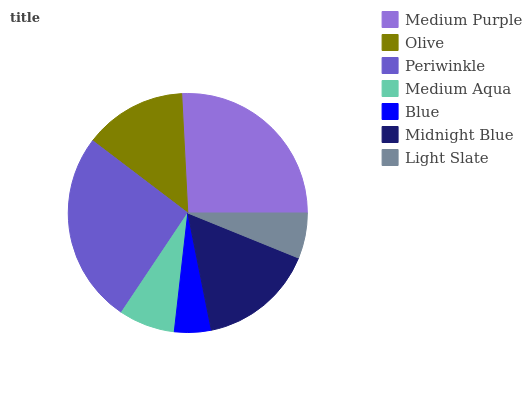Is Blue the minimum?
Answer yes or no. Yes. Is Periwinkle the maximum?
Answer yes or no. Yes. Is Olive the minimum?
Answer yes or no. No. Is Olive the maximum?
Answer yes or no. No. Is Medium Purple greater than Olive?
Answer yes or no. Yes. Is Olive less than Medium Purple?
Answer yes or no. Yes. Is Olive greater than Medium Purple?
Answer yes or no. No. Is Medium Purple less than Olive?
Answer yes or no. No. Is Olive the high median?
Answer yes or no. Yes. Is Olive the low median?
Answer yes or no. Yes. Is Periwinkle the high median?
Answer yes or no. No. Is Blue the low median?
Answer yes or no. No. 